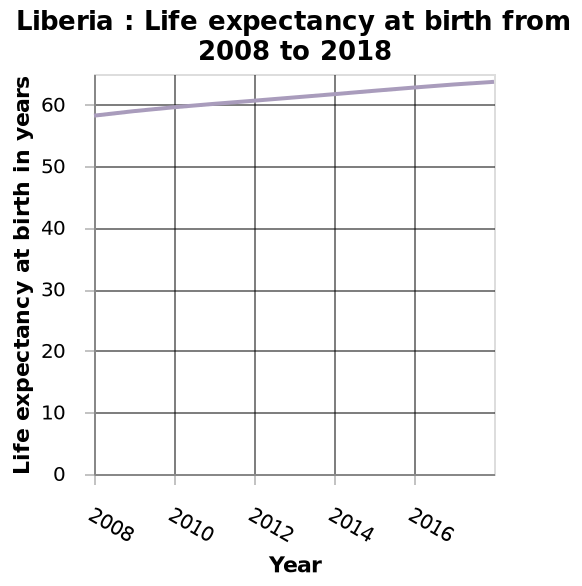<image>
What type of chart represents the life expectancy at birth in Liberia from 2008 to 2018?  A line chart represents the life expectancy at birth in Liberia from 2008 to 2018. What is plotted on the x-axis of the chart?  The x-axis of the chart plots the years from 2008 to 2018. What information does the line chart provide about Liberia's life expectancy at birth over the specified period? The line chart shows the trend and changes in Liberia's life expectancy at birth from 2008 to 2018. Has life expectancy at birth decreased or increased in Liberia?  Life expectancy at birth has increased in Liberia. 